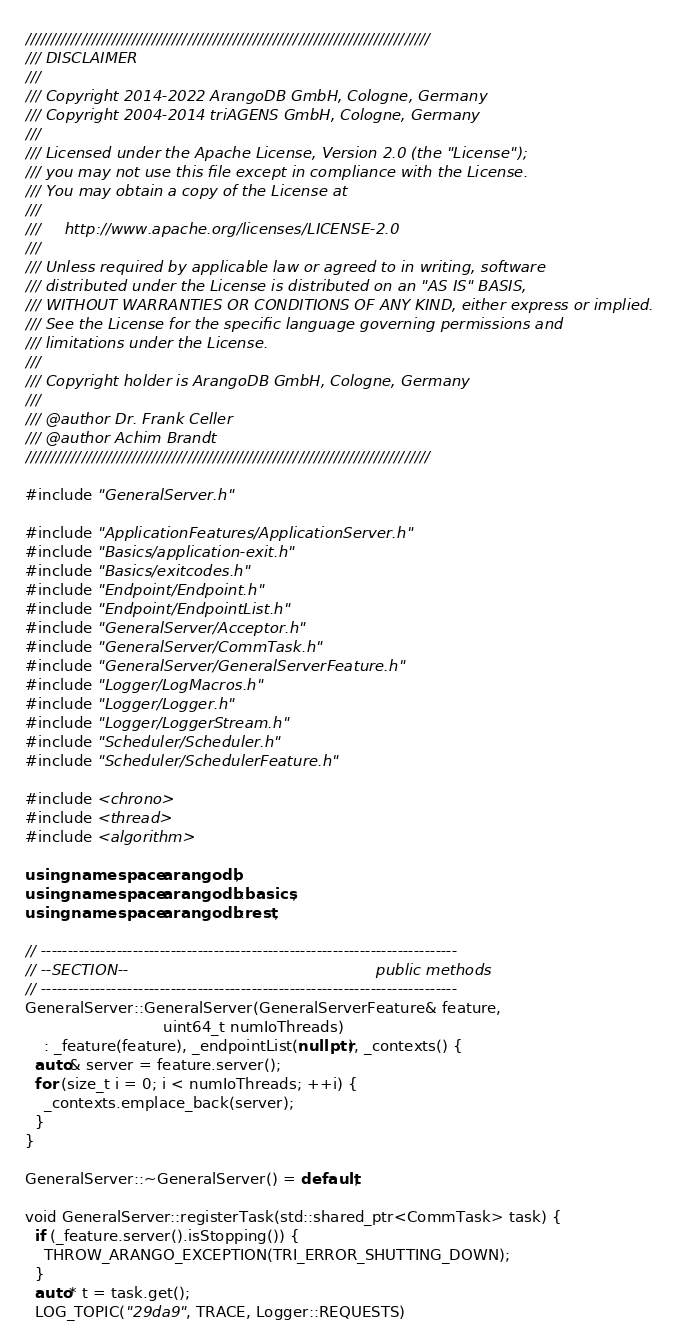Convert code to text. <code><loc_0><loc_0><loc_500><loc_500><_C++_>////////////////////////////////////////////////////////////////////////////////
/// DISCLAIMER
///
/// Copyright 2014-2022 ArangoDB GmbH, Cologne, Germany
/// Copyright 2004-2014 triAGENS GmbH, Cologne, Germany
///
/// Licensed under the Apache License, Version 2.0 (the "License");
/// you may not use this file except in compliance with the License.
/// You may obtain a copy of the License at
///
///     http://www.apache.org/licenses/LICENSE-2.0
///
/// Unless required by applicable law or agreed to in writing, software
/// distributed under the License is distributed on an "AS IS" BASIS,
/// WITHOUT WARRANTIES OR CONDITIONS OF ANY KIND, either express or implied.
/// See the License for the specific language governing permissions and
/// limitations under the License.
///
/// Copyright holder is ArangoDB GmbH, Cologne, Germany
///
/// @author Dr. Frank Celler
/// @author Achim Brandt
////////////////////////////////////////////////////////////////////////////////

#include "GeneralServer.h"

#include "ApplicationFeatures/ApplicationServer.h"
#include "Basics/application-exit.h"
#include "Basics/exitcodes.h"
#include "Endpoint/Endpoint.h"
#include "Endpoint/EndpointList.h"
#include "GeneralServer/Acceptor.h"
#include "GeneralServer/CommTask.h"
#include "GeneralServer/GeneralServerFeature.h"
#include "Logger/LogMacros.h"
#include "Logger/Logger.h"
#include "Logger/LoggerStream.h"
#include "Scheduler/Scheduler.h"
#include "Scheduler/SchedulerFeature.h"

#include <chrono>
#include <thread>
#include <algorithm>

using namespace arangodb;
using namespace arangodb::basics;
using namespace arangodb::rest;

// -----------------------------------------------------------------------------
// --SECTION--                                                    public methods
// -----------------------------------------------------------------------------
GeneralServer::GeneralServer(GeneralServerFeature& feature,
                             uint64_t numIoThreads)
    : _feature(feature), _endpointList(nullptr), _contexts() {
  auto& server = feature.server();
  for (size_t i = 0; i < numIoThreads; ++i) {
    _contexts.emplace_back(server);
  }
}

GeneralServer::~GeneralServer() = default;

void GeneralServer::registerTask(std::shared_ptr<CommTask> task) {
  if (_feature.server().isStopping()) {
    THROW_ARANGO_EXCEPTION(TRI_ERROR_SHUTTING_DOWN);
  }
  auto* t = task.get();
  LOG_TOPIC("29da9", TRACE, Logger::REQUESTS)</code> 